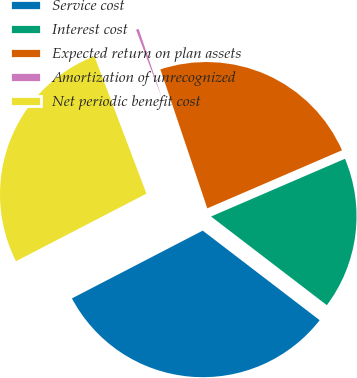<chart> <loc_0><loc_0><loc_500><loc_500><pie_chart><fcel>Service cost<fcel>Interest cost<fcel>Expected return on plan assets<fcel>Amortization of unrecognized<fcel>Net periodic benefit cost<nl><fcel>31.99%<fcel>16.88%<fcel>23.7%<fcel>0.59%<fcel>26.84%<nl></chart> 